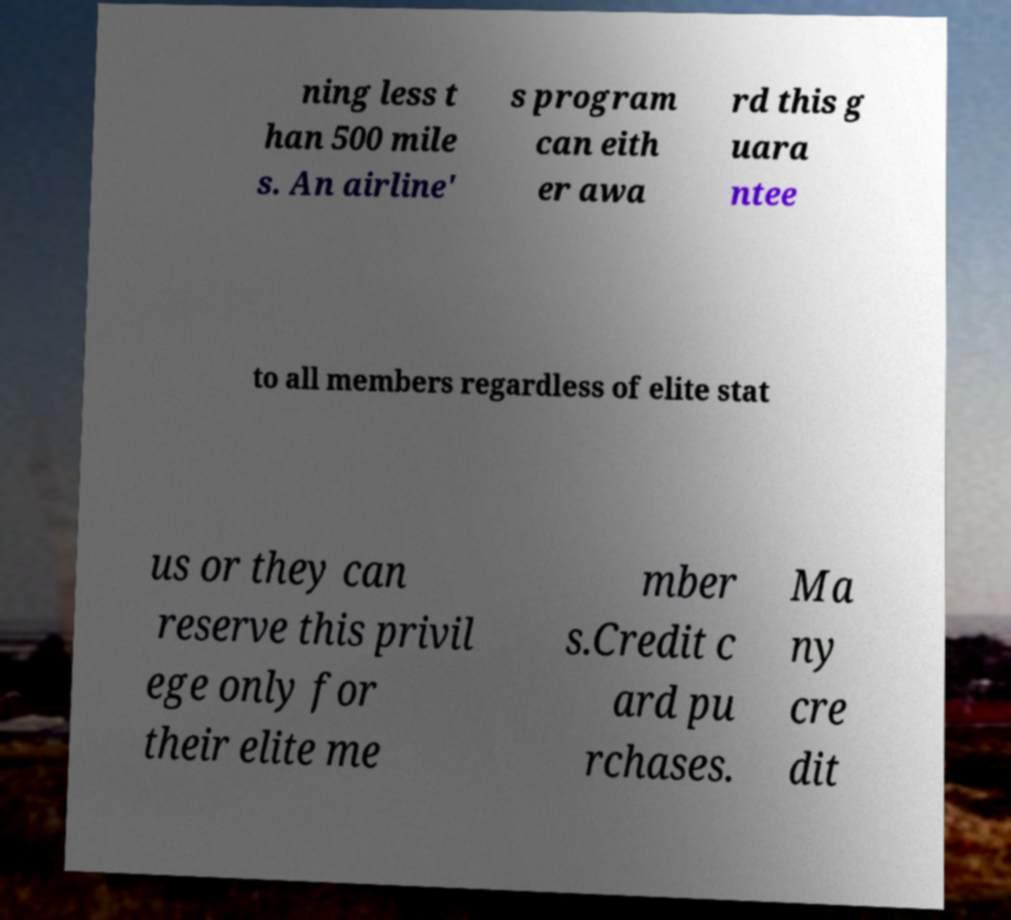Please identify and transcribe the text found in this image. ning less t han 500 mile s. An airline' s program can eith er awa rd this g uara ntee to all members regardless of elite stat us or they can reserve this privil ege only for their elite me mber s.Credit c ard pu rchases. Ma ny cre dit 